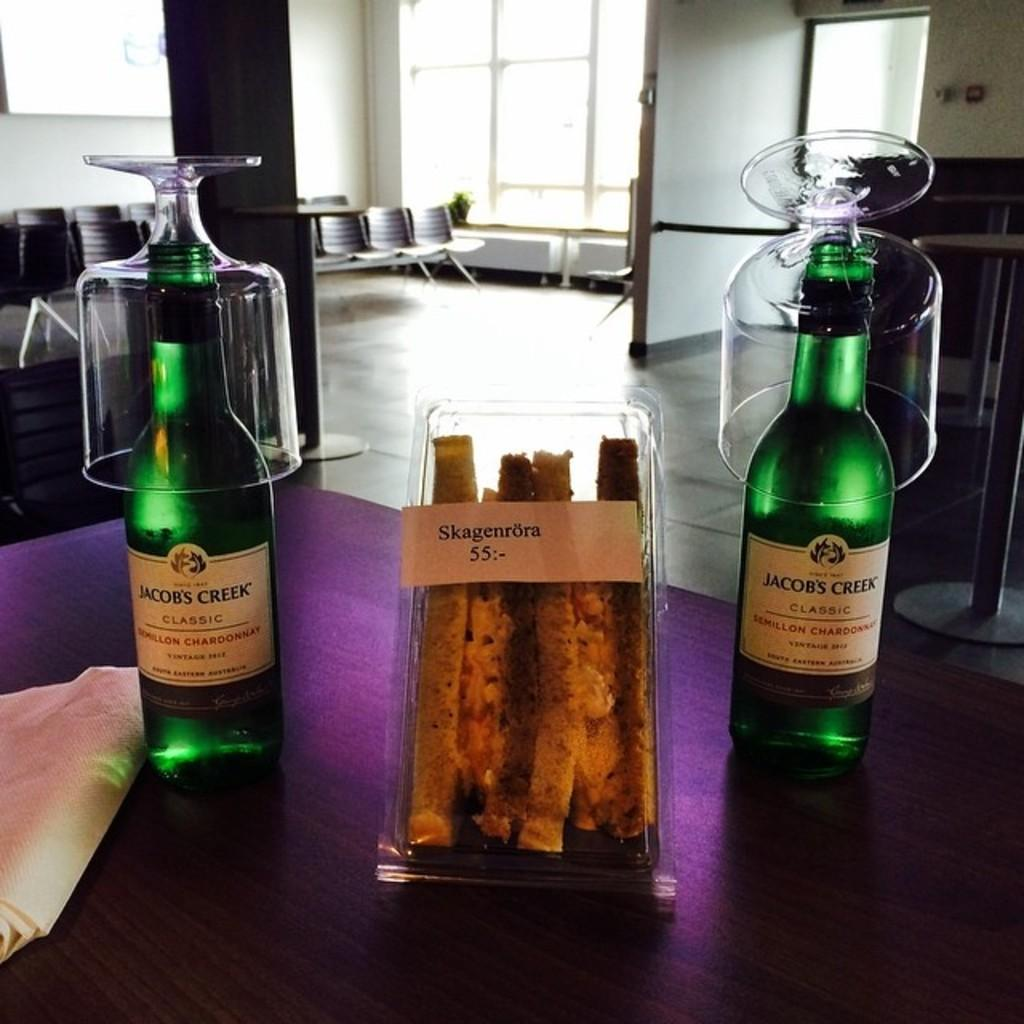<image>
Render a clear and concise summary of the photo. two beer bottles that say Jacob's Creek on them 